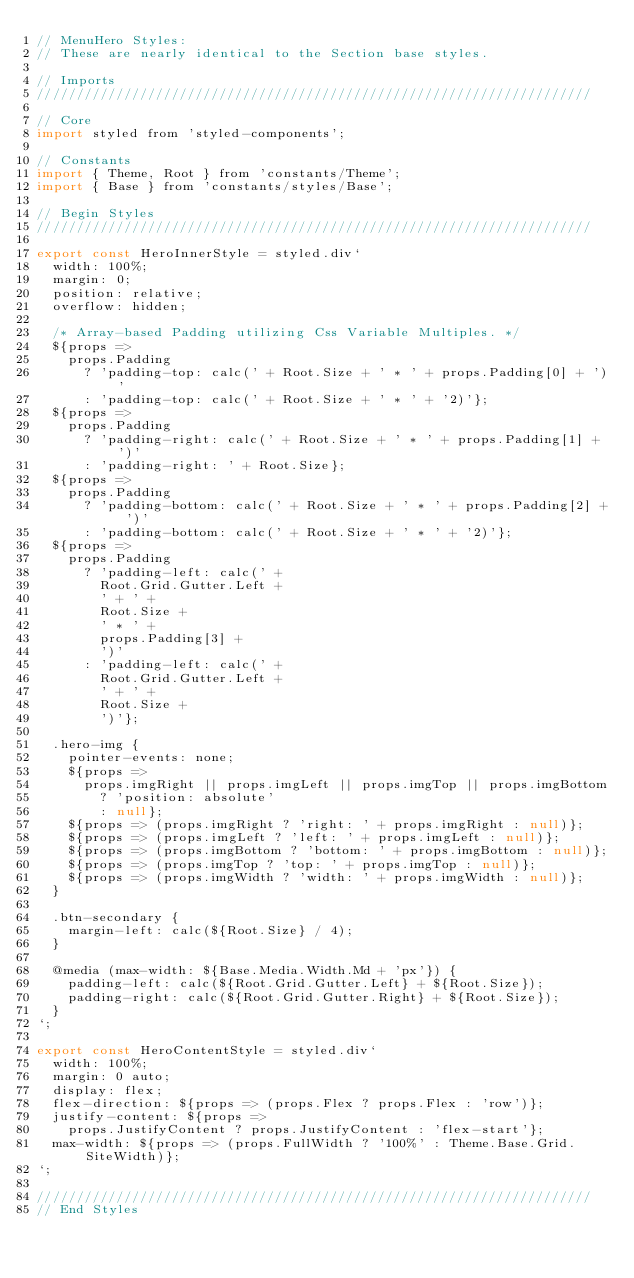Convert code to text. <code><loc_0><loc_0><loc_500><loc_500><_JavaScript_>// MenuHero Styles:
// These are nearly identical to the Section base styles.

// Imports
//////////////////////////////////////////////////////////////////////

// Core
import styled from 'styled-components';

// Constants
import { Theme, Root } from 'constants/Theme';
import { Base } from 'constants/styles/Base';

// Begin Styles
//////////////////////////////////////////////////////////////////////

export const HeroInnerStyle = styled.div`
  width: 100%;
  margin: 0;
  position: relative;
  overflow: hidden;

  /* Array-based Padding utilizing Css Variable Multiples. */
  ${props =>
    props.Padding
      ? 'padding-top: calc(' + Root.Size + ' * ' + props.Padding[0] + ')'
      : 'padding-top: calc(' + Root.Size + ' * ' + '2)'};
  ${props =>
    props.Padding
      ? 'padding-right: calc(' + Root.Size + ' * ' + props.Padding[1] + ')'
      : 'padding-right: ' + Root.Size};
  ${props =>
    props.Padding
      ? 'padding-bottom: calc(' + Root.Size + ' * ' + props.Padding[2] + ')'
      : 'padding-bottom: calc(' + Root.Size + ' * ' + '2)'};
  ${props =>
    props.Padding
      ? 'padding-left: calc(' +
        Root.Grid.Gutter.Left +
        ' + ' +
        Root.Size +
        ' * ' +
        props.Padding[3] +
        ')'
      : 'padding-left: calc(' +
        Root.Grid.Gutter.Left +
        ' + ' +
        Root.Size +
        ')'};

  .hero-img {
    pointer-events: none;
    ${props =>
      props.imgRight || props.imgLeft || props.imgTop || props.imgBottom
        ? 'position: absolute'
        : null};
    ${props => (props.imgRight ? 'right: ' + props.imgRight : null)};
    ${props => (props.imgLeft ? 'left: ' + props.imgLeft : null)};
    ${props => (props.imgBottom ? 'bottom: ' + props.imgBottom : null)};
    ${props => (props.imgTop ? 'top: ' + props.imgTop : null)};
    ${props => (props.imgWidth ? 'width: ' + props.imgWidth : null)};
  }

  .btn-secondary {
    margin-left: calc(${Root.Size} / 4);
  }

  @media (max-width: ${Base.Media.Width.Md + 'px'}) {
    padding-left: calc(${Root.Grid.Gutter.Left} + ${Root.Size});
    padding-right: calc(${Root.Grid.Gutter.Right} + ${Root.Size});
  }
`;

export const HeroContentStyle = styled.div`
  width: 100%;
  margin: 0 auto;
  display: flex;
  flex-direction: ${props => (props.Flex ? props.Flex : 'row')};
  justify-content: ${props =>
    props.JustifyContent ? props.JustifyContent : 'flex-start'};
  max-width: ${props => (props.FullWidth ? '100%' : Theme.Base.Grid.SiteWidth)};
`;

//////////////////////////////////////////////////////////////////////
// End Styles
</code> 